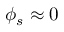Convert formula to latex. <formula><loc_0><loc_0><loc_500><loc_500>\phi _ { s } \approx 0</formula> 